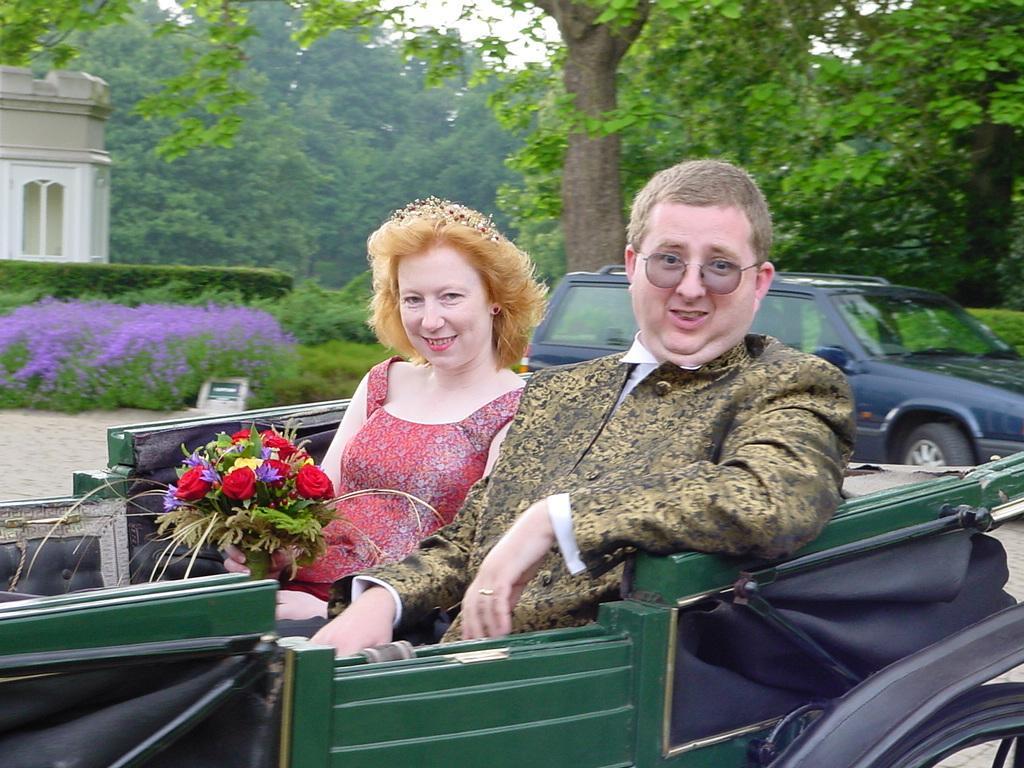In one or two sentences, can you explain what this image depicts? In this image we have a man and a woman sitting in the car and a woman catching a flower bouquet and at the back ground we have a car , tree , a building and plants. 